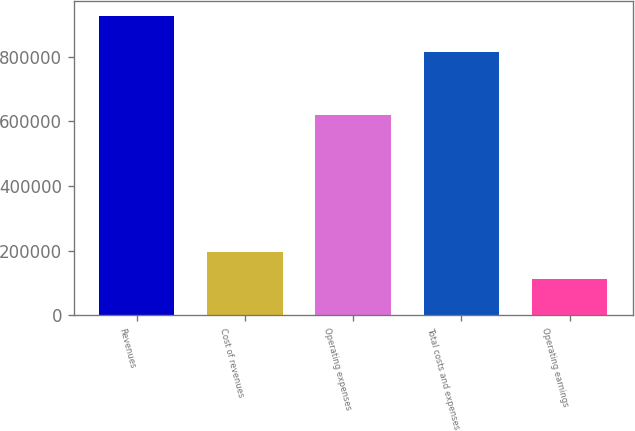<chart> <loc_0><loc_0><loc_500><loc_500><bar_chart><fcel>Revenues<fcel>Cost of revenues<fcel>Operating expenses<fcel>Total costs and expenses<fcel>Operating earnings<nl><fcel>926356<fcel>196348<fcel>618544<fcel>814892<fcel>111464<nl></chart> 